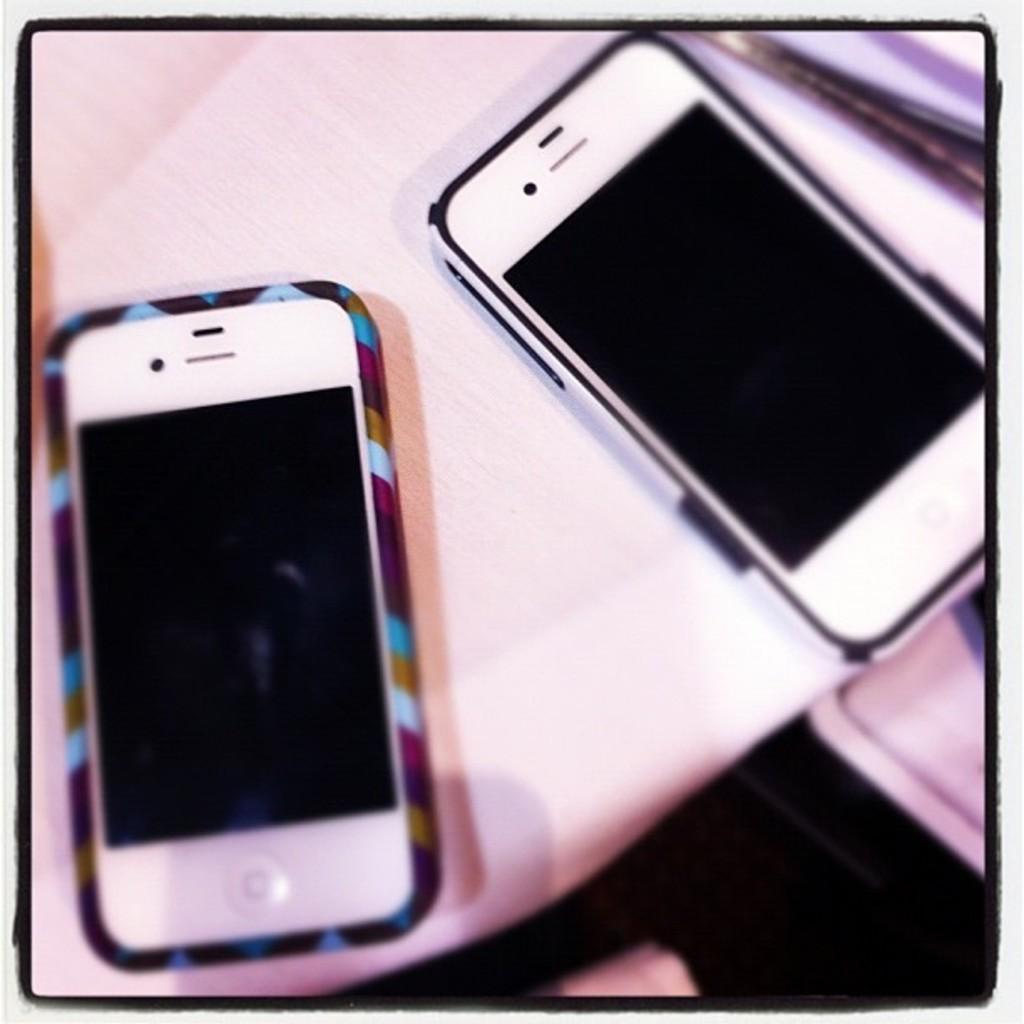How would you summarize this image in a sentence or two? In this image we can see a photo. In the photo we can see two mobiles on a white surface. 